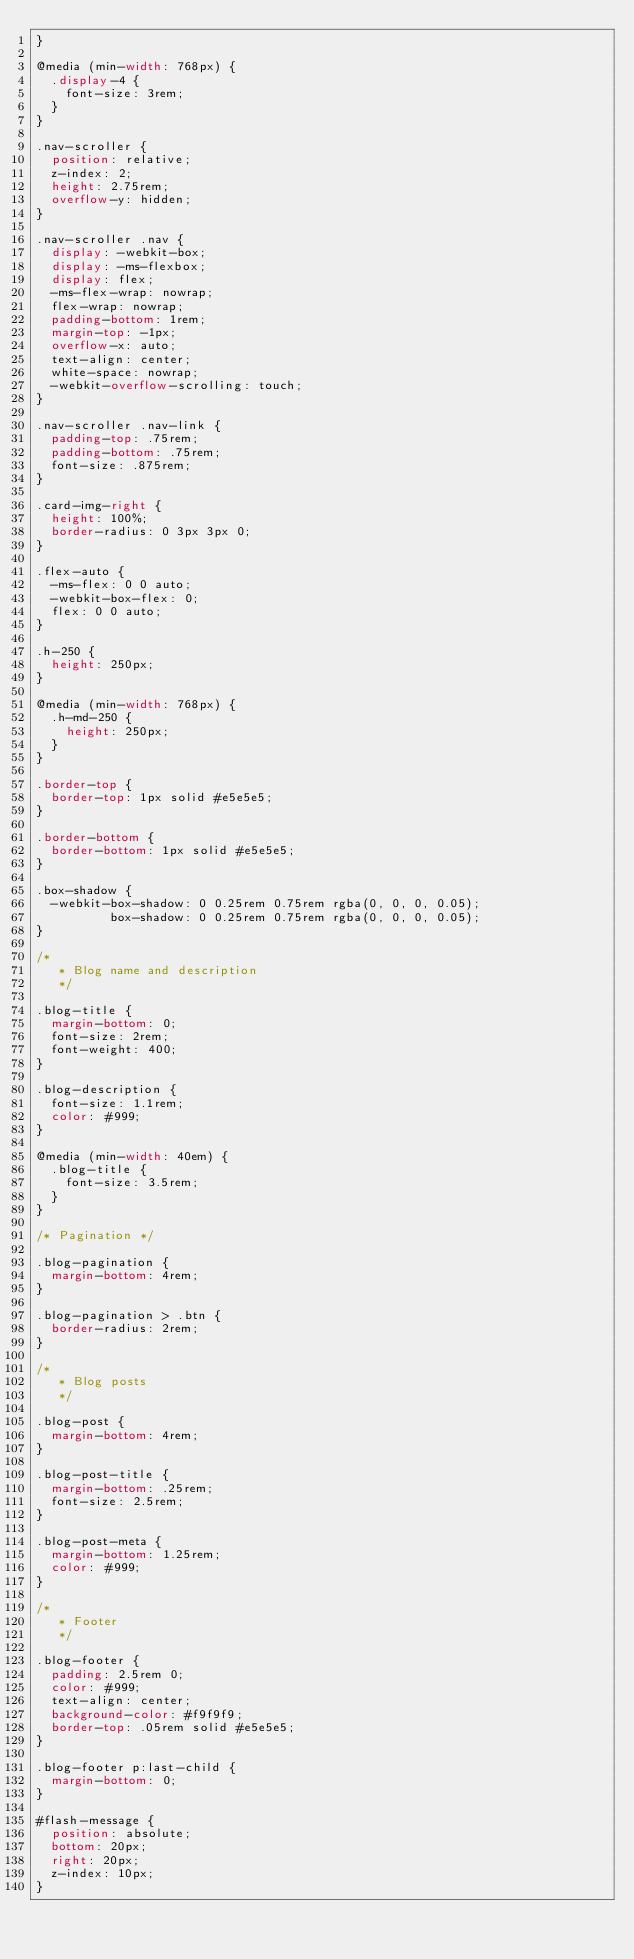<code> <loc_0><loc_0><loc_500><loc_500><_CSS_>}

@media (min-width: 768px) {
  .display-4 {
    font-size: 3rem;
  }
}

.nav-scroller {
  position: relative;
  z-index: 2;
  height: 2.75rem;
  overflow-y: hidden;
}

.nav-scroller .nav {
  display: -webkit-box;
  display: -ms-flexbox;
  display: flex;
  -ms-flex-wrap: nowrap;
  flex-wrap: nowrap;
  padding-bottom: 1rem;
  margin-top: -1px;
  overflow-x: auto;
  text-align: center;
  white-space: nowrap;
  -webkit-overflow-scrolling: touch;
}

.nav-scroller .nav-link {
  padding-top: .75rem;
  padding-bottom: .75rem;
  font-size: .875rem;
}

.card-img-right {
  height: 100%;
  border-radius: 0 3px 3px 0;
}

.flex-auto {
  -ms-flex: 0 0 auto;
  -webkit-box-flex: 0;
  flex: 0 0 auto;
}

.h-250 {
  height: 250px;
}

@media (min-width: 768px) {
  .h-md-250 {
    height: 250px;
  }
}

.border-top {
  border-top: 1px solid #e5e5e5;
}

.border-bottom {
  border-bottom: 1px solid #e5e5e5;
}

.box-shadow {
  -webkit-box-shadow: 0 0.25rem 0.75rem rgba(0, 0, 0, 0.05);
          box-shadow: 0 0.25rem 0.75rem rgba(0, 0, 0, 0.05);
}

/*
   * Blog name and description
   */

.blog-title {
  margin-bottom: 0;
  font-size: 2rem;
  font-weight: 400;
}

.blog-description {
  font-size: 1.1rem;
  color: #999;
}

@media (min-width: 40em) {
  .blog-title {
    font-size: 3.5rem;
  }
}

/* Pagination */

.blog-pagination {
  margin-bottom: 4rem;
}

.blog-pagination > .btn {
  border-radius: 2rem;
}

/*
   * Blog posts
   */

.blog-post {
  margin-bottom: 4rem;
}

.blog-post-title {
  margin-bottom: .25rem;
  font-size: 2.5rem;
}

.blog-post-meta {
  margin-bottom: 1.25rem;
  color: #999;
}

/*
   * Footer
   */

.blog-footer {
  padding: 2.5rem 0;
  color: #999;
  text-align: center;
  background-color: #f9f9f9;
  border-top: .05rem solid #e5e5e5;
}

.blog-footer p:last-child {
  margin-bottom: 0;
}

#flash-message {
  position: absolute;
  bottom: 20px;
  right: 20px;
  z-index: 10px;
}

</code> 